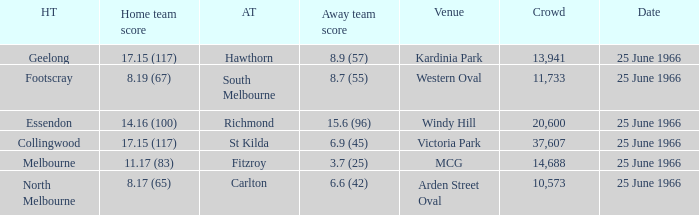What is the total crowd size when a home team scored 17.15 (117) versus hawthorn? 13941.0. 